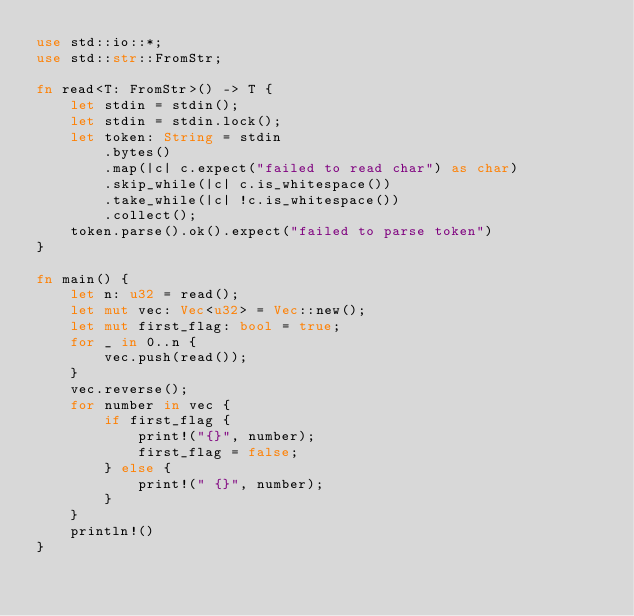<code> <loc_0><loc_0><loc_500><loc_500><_Rust_>use std::io::*;
use std::str::FromStr;

fn read<T: FromStr>() -> T {
    let stdin = stdin();
    let stdin = stdin.lock();
    let token: String = stdin
        .bytes()
        .map(|c| c.expect("failed to read char") as char)
        .skip_while(|c| c.is_whitespace())
        .take_while(|c| !c.is_whitespace())
        .collect();
    token.parse().ok().expect("failed to parse token")
}

fn main() {
    let n: u32 = read();
    let mut vec: Vec<u32> = Vec::new();
    let mut first_flag: bool = true;
    for _ in 0..n {
        vec.push(read());
    }
    vec.reverse();
    for number in vec {
        if first_flag {
            print!("{}", number);
            first_flag = false;
        } else {
            print!(" {}", number);
        }
    }
    println!()
}

</code> 